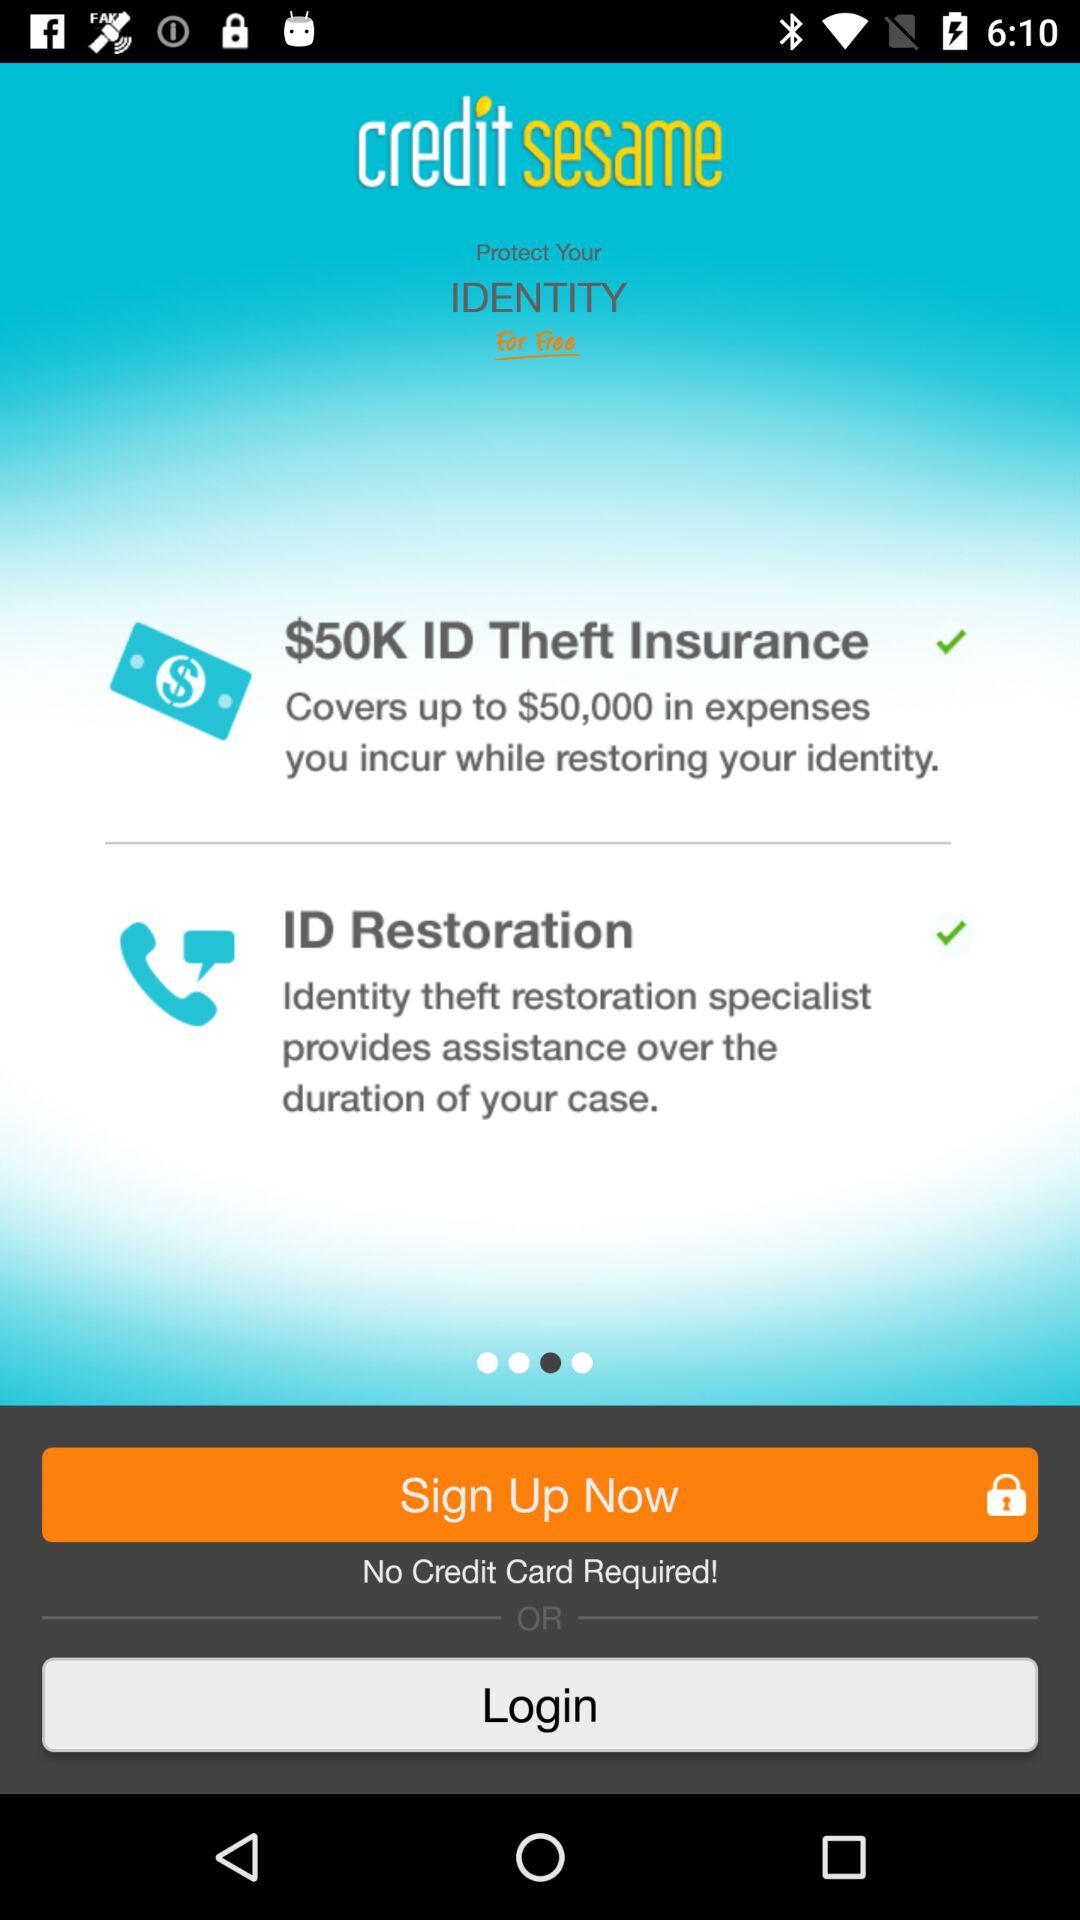What is the application name? The application name is "credit sesame". 